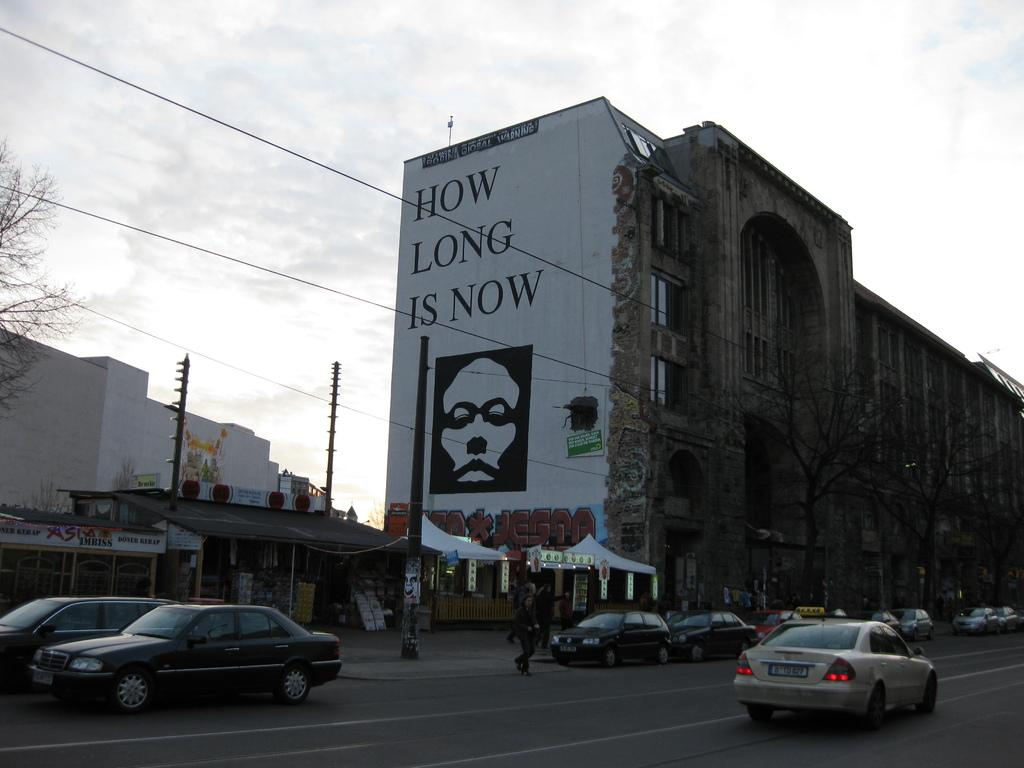What type of vehicles can be seen on the road in the image? There are cars on the road in the image. Can you identify any living beings in the image? Yes, there are people visible in the image. What structures are present in the image? There are poles, trees, boards, and buildings in the image. What is visible in the background of the image? The sky is visible in the background of the image. What type of box is being used to show respect to the substance in the image? There is no box, respect, or substance present in the image. 